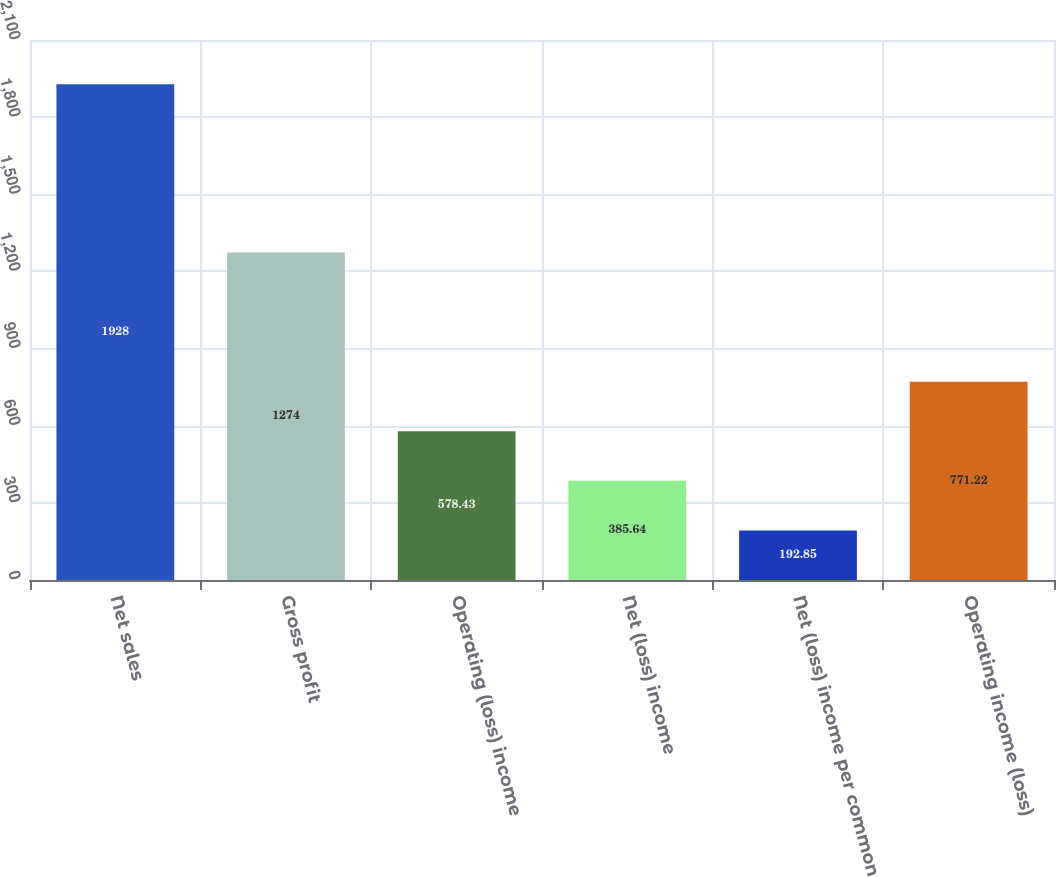Convert chart. <chart><loc_0><loc_0><loc_500><loc_500><bar_chart><fcel>Net sales<fcel>Gross profit<fcel>Operating (loss) income<fcel>Net (loss) income<fcel>Net (loss) income per common<fcel>Operating income (loss)<nl><fcel>1928<fcel>1274<fcel>578.43<fcel>385.64<fcel>192.85<fcel>771.22<nl></chart> 